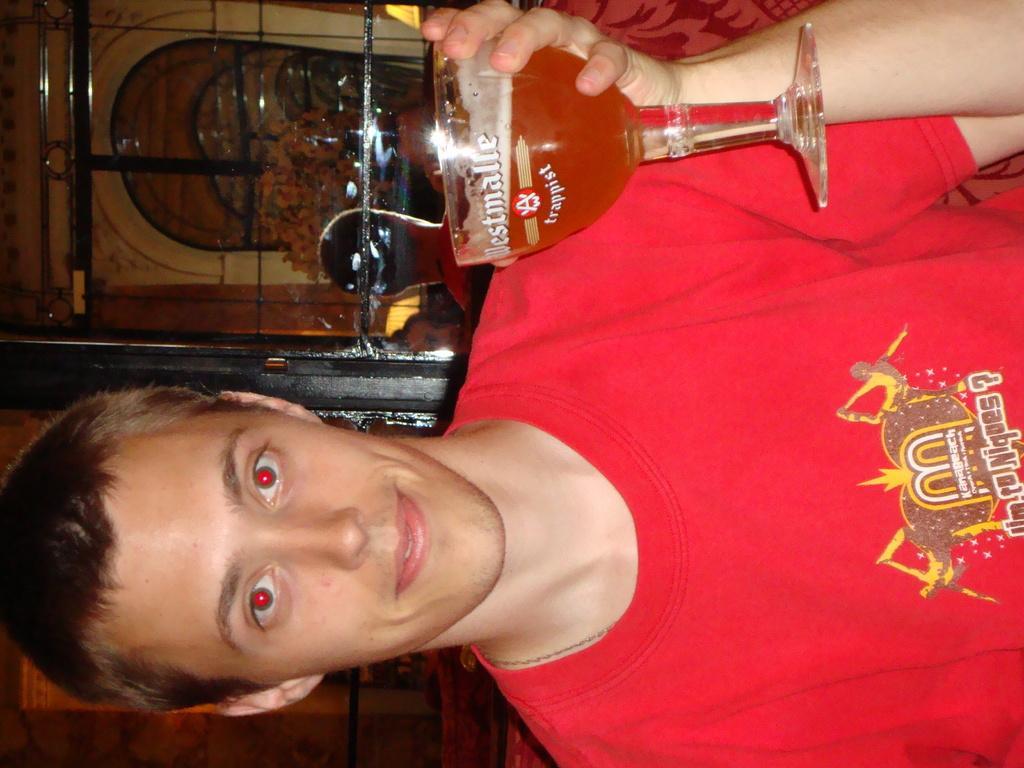Please provide a concise description of this image. In this picture I can see a man holding a glass in his hand and I can see he wore a red color t-shirt. 